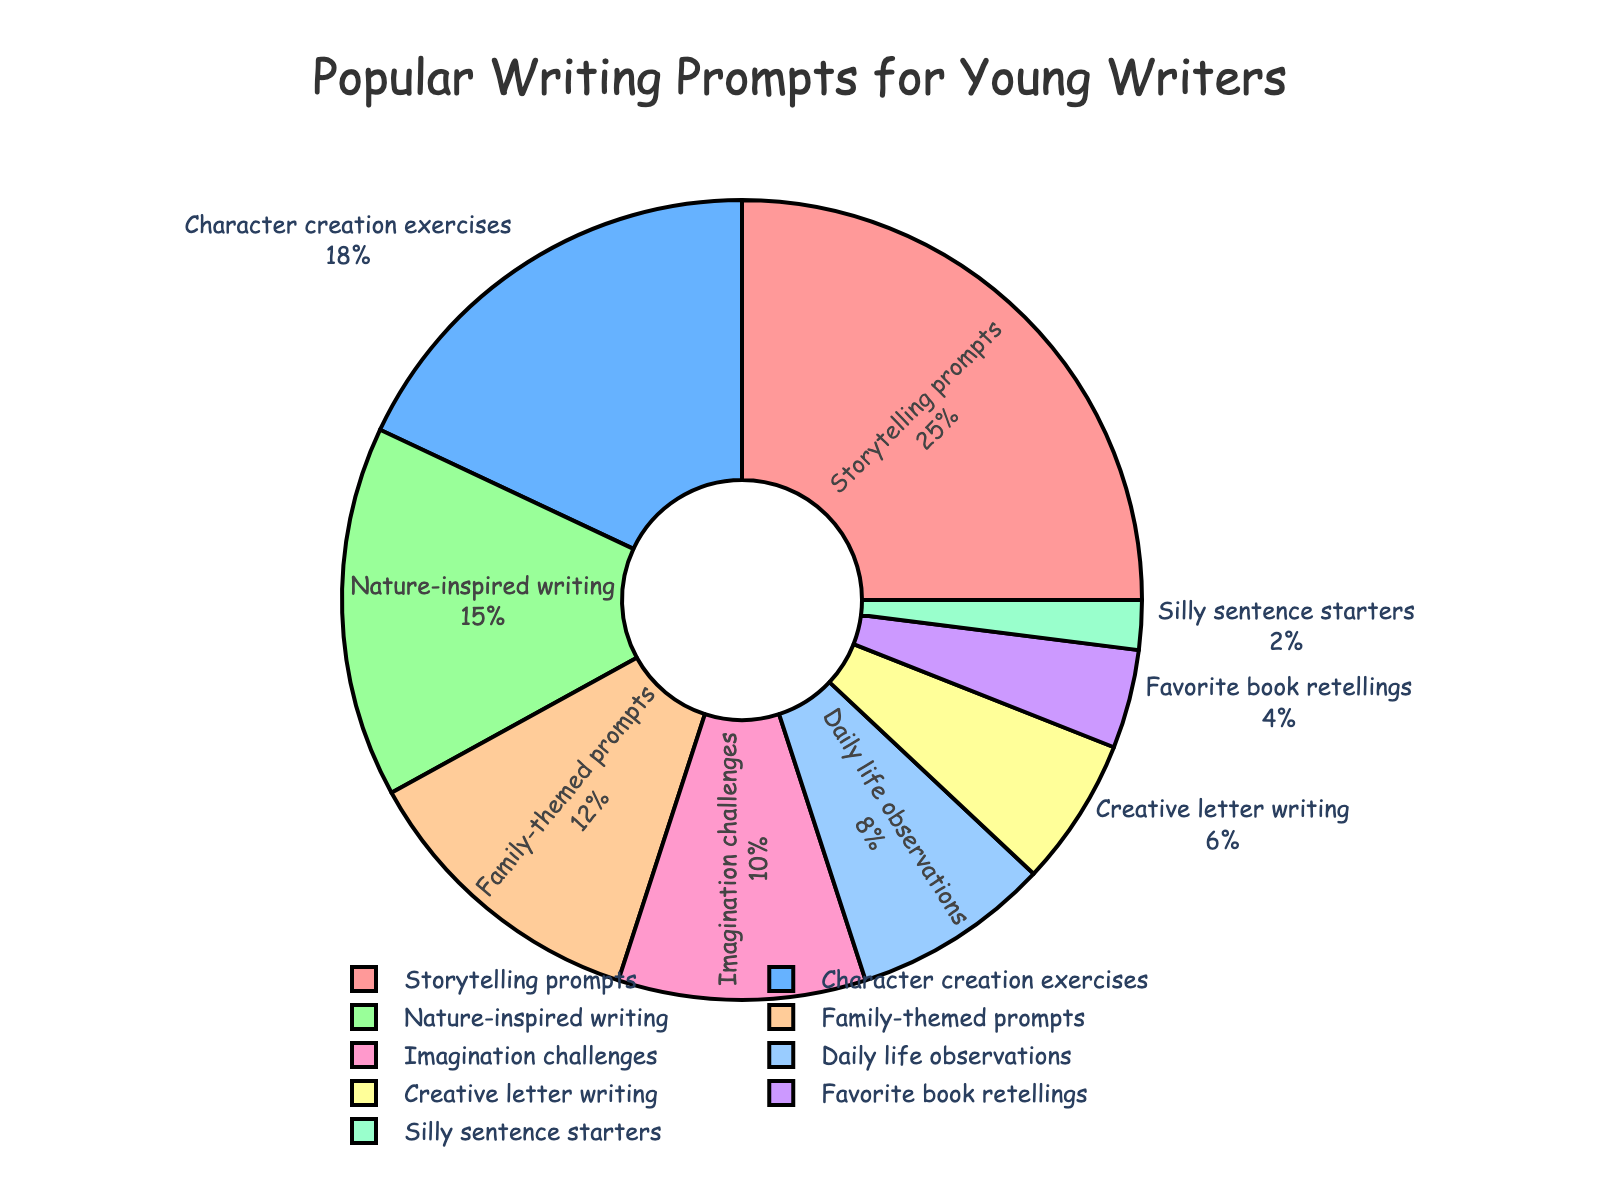Which category has the highest percentage? The pie chart shows the largest section is labeled "Storytelling prompts" with 25%.
Answer: Storytelling prompts Which two categories have the smallest percentages? From the pie chart, the smallest sections are labeled "Silly sentence starters" and "Favorite book retellings" with 2% and 4%, respectively.
Answer: Silly sentence starters, Favorite book retellings What is the combined percentage of Family-themed prompts and Nature-inspired writing? Family-themed prompts have 12% and Nature-inspired writing has 15%. Adding these together, 12% + 15% = 27%.
Answer: 27% Which category is closest in percentage to Creative letter writing? Creative letter writing is at 6%. Daily life observations at 8% is the closest.
Answer: Daily life observations Is the percentage of Imagination challenges greater than the combined percentage of Silly sentence starters and Favorite book retellings? Imagination challenges are 10%. The sum of Silly sentence starters (2%) and Favorite book retellings (4%) is 6%, so 10% is greater than 6%.
Answer: Yes By how much does the percentage of Storytelling prompts exceed the percentage of Character creation exercises? Storytelling prompts are 25% and Character creation exercises are 18%. The difference is 25% - 18% = 7%.
Answer: 7% Which categories together make up exactly 33% of the total? Nature-inspired writing (15%), Daily life observations (8%), and Creative letter writing (6%) together make 15% + 8% + 6% = 29%, not quite 33%. But Nature-inspired writing (15%) and Imagination challenges (10%) along with Family-themed prompts (12%) make 15% + 10% + 12% = 37%. No exact combination correctly sums to 33%.
Answer: None What is the percentage difference between the largest and smallest categories? The largest is Storytelling prompts at 25% and the smallest is Silly sentence starters at 2%. The difference is 25% - 2% = 23%.
Answer: 23% If you group the categories into ones greater than or equal to 10% and less than 10%, how many categories are in each group? Categories >= 10%: Storytelling prompts (25%), Character creation exercises (18%), Nature-inspired writing (15%), Family-themed prompts (12%), Imagination challenges (10%). This gives 5 categories. Categories < 10%: Daily life observations (8%), Creative letter writing (6%), Favorite book retellings (4%), Silly sentence starters (2%). This gives 4 categories.
Answer: 5, 4 